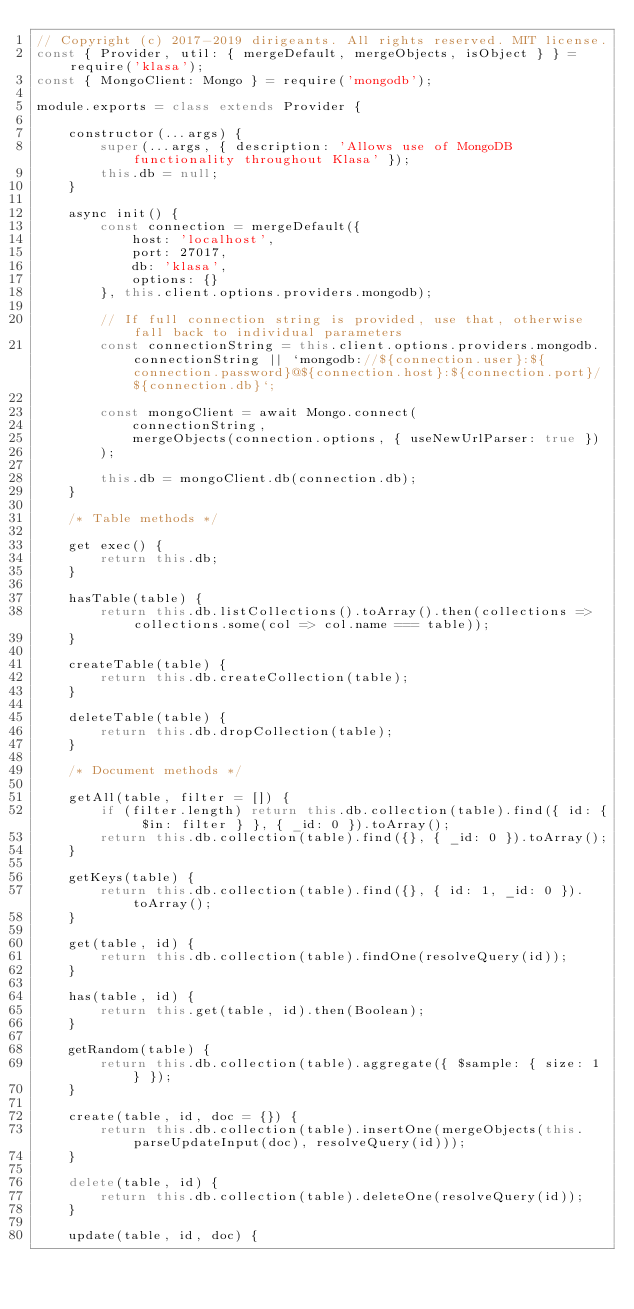Convert code to text. <code><loc_0><loc_0><loc_500><loc_500><_JavaScript_>// Copyright (c) 2017-2019 dirigeants. All rights reserved. MIT license.
const { Provider, util: { mergeDefault, mergeObjects, isObject } } = require('klasa');
const { MongoClient: Mongo } = require('mongodb');

module.exports = class extends Provider {

	constructor(...args) {
		super(...args, { description: 'Allows use of MongoDB functionality throughout Klasa' });
		this.db = null;
	}

	async init() {
		const connection = mergeDefault({
			host: 'localhost',
			port: 27017,
			db: 'klasa',
			options: {}
		}, this.client.options.providers.mongodb);

		// If full connection string is provided, use that, otherwise fall back to individual parameters
		const connectionString = this.client.options.providers.mongodb.connectionString || `mongodb://${connection.user}:${connection.password}@${connection.host}:${connection.port}/${connection.db}`;

		const mongoClient = await Mongo.connect(
			connectionString,
			mergeObjects(connection.options, { useNewUrlParser: true })
		);

		this.db = mongoClient.db(connection.db);
	}

	/* Table methods */

	get exec() {
		return this.db;
	}

	hasTable(table) {
		return this.db.listCollections().toArray().then(collections => collections.some(col => col.name === table));
	}

	createTable(table) {
		return this.db.createCollection(table);
	}

	deleteTable(table) {
		return this.db.dropCollection(table);
	}

	/* Document methods */

	getAll(table, filter = []) {
		if (filter.length) return this.db.collection(table).find({ id: { $in: filter } }, { _id: 0 }).toArray();
		return this.db.collection(table).find({}, { _id: 0 }).toArray();
	}

	getKeys(table) {
		return this.db.collection(table).find({}, { id: 1, _id: 0 }).toArray();
	}

	get(table, id) {
		return this.db.collection(table).findOne(resolveQuery(id));
	}

	has(table, id) {
		return this.get(table, id).then(Boolean);
	}

	getRandom(table) {
		return this.db.collection(table).aggregate({ $sample: { size: 1 } });
	}

	create(table, id, doc = {}) {
		return this.db.collection(table).insertOne(mergeObjects(this.parseUpdateInput(doc), resolveQuery(id)));
	}

	delete(table, id) {
		return this.db.collection(table).deleteOne(resolveQuery(id));
	}

	update(table, id, doc) {</code> 